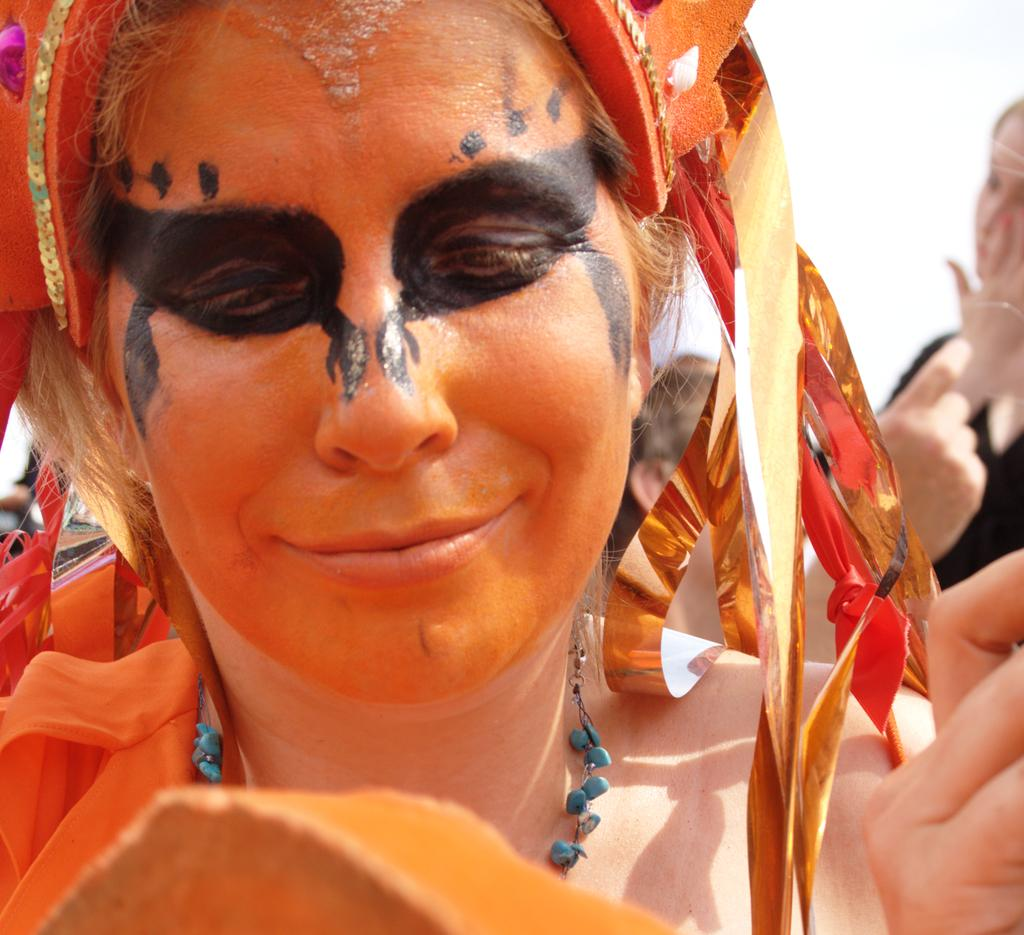Who is present in the image? There is a woman in the image. What is the woman doing in the image? The woman is smiling in the image. What accessory is the woman wearing? The woman is wearing a neck chain in the image. What is unique about the woman's appearance? There is a painting on the woman's face in the image. Can you describe the other people visible in the image? There are other people visible in the image, and they are wearing clothes. What can be seen in the background of the image? The sky is visible in the background of the image. What type of wilderness can be seen in the background of the image? There is no wilderness visible in the background of the image; it is the sky that can be seen. How does the woman use the loaf in the image? There is no loaf present in the image, so it cannot be used by the woman. 